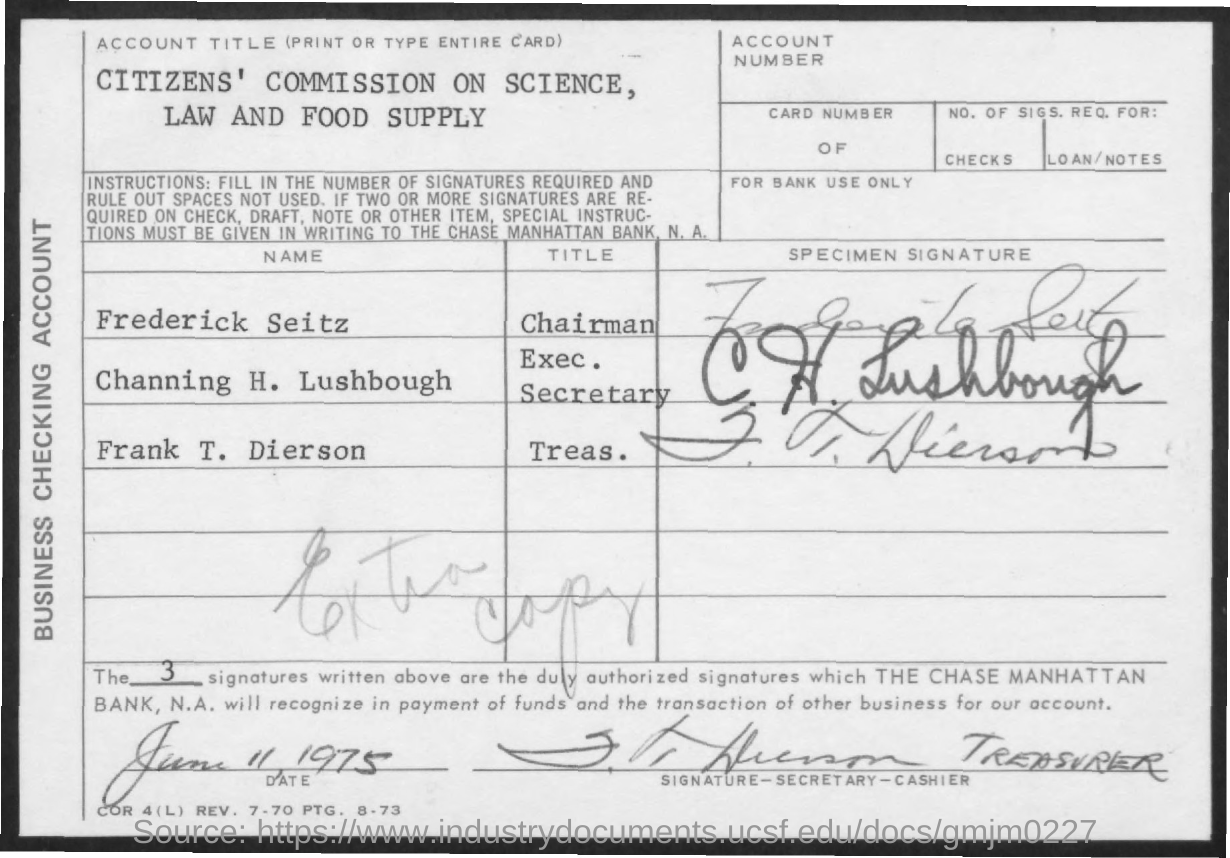Draw attention to some important aspects in this diagram. Frederick Seitz is the chairman of a title mentioned. The date mentioned is June 11, 1975. What is the name of the title mentioned for Frank T. Dierson? Treasurer. Channing H. Lushbough is the executive secretary mentioned in the title. 